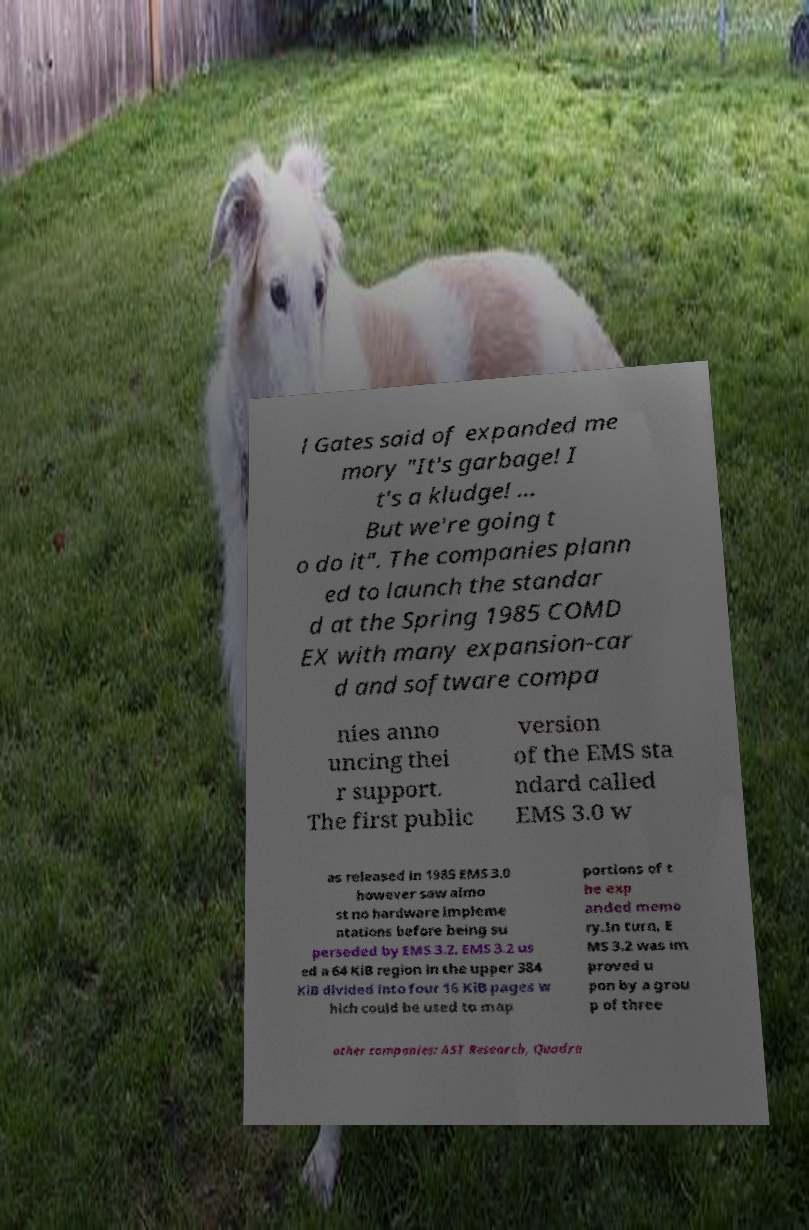Can you read and provide the text displayed in the image?This photo seems to have some interesting text. Can you extract and type it out for me? l Gates said of expanded me mory "It's garbage! I t's a kludge! … But we're going t o do it". The companies plann ed to launch the standar d at the Spring 1985 COMD EX with many expansion-car d and software compa nies anno uncing thei r support. The first public version of the EMS sta ndard called EMS 3.0 w as released in 1985 EMS 3.0 however saw almo st no hardware impleme ntations before being su perseded by EMS 3.2. EMS 3.2 us ed a 64 KiB region in the upper 384 KiB divided into four 16 KiB pages w hich could be used to map portions of t he exp anded memo ry.In turn, E MS 3.2 was im proved u pon by a grou p of three other companies: AST Research, Quadra 